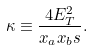Convert formula to latex. <formula><loc_0><loc_0><loc_500><loc_500>\kappa \equiv \frac { 4 E ^ { 2 } _ { T } } { x _ { a } x _ { b } s } .</formula> 